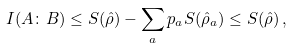<formula> <loc_0><loc_0><loc_500><loc_500>I ( A \colon B ) \leq S ( \hat { \rho } ) - \sum _ { a } p _ { a } S ( \hat { \rho } _ { a } ) \leq S ( \hat { \rho } ) \, ,</formula> 